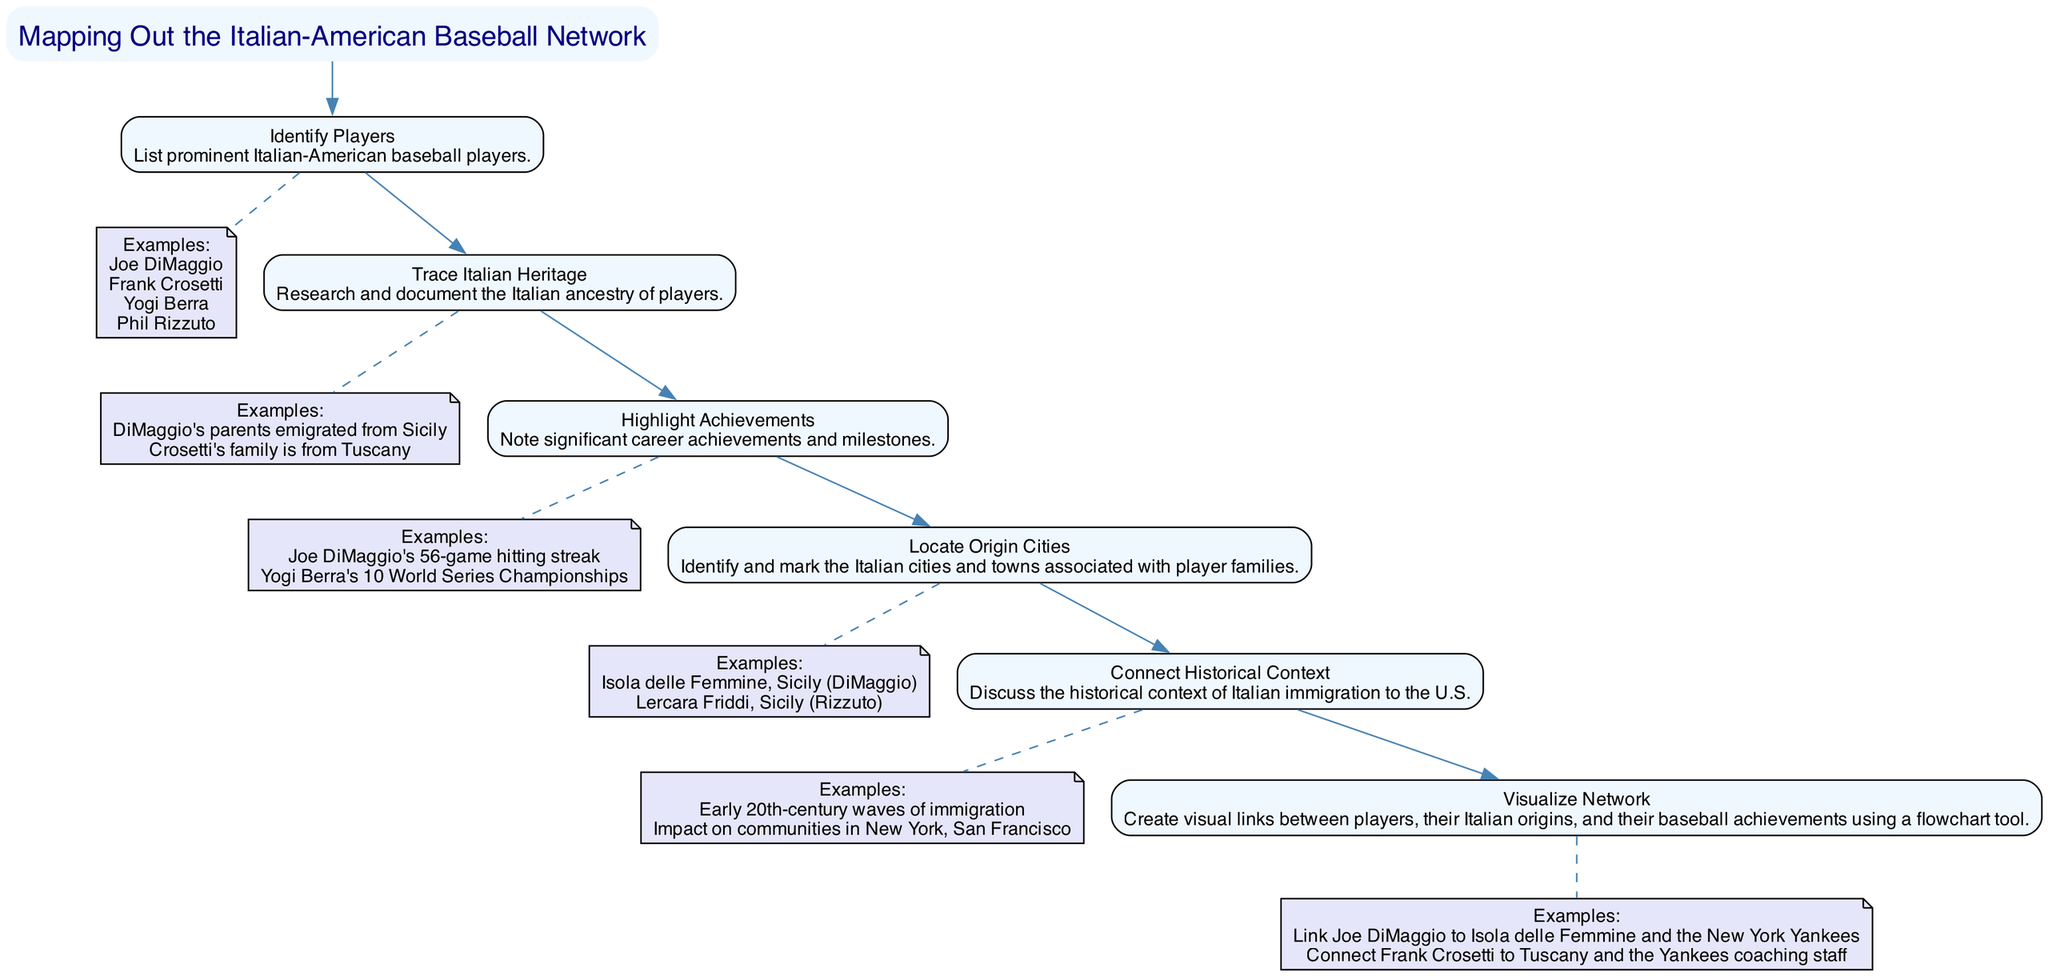What is the first step in the diagram? The first step in the flowchart is "Identify Players." This can be found as the first node after the title, which outlines the initial action in mapping out the Italian-American baseball network.
Answer: Identify Players How many prominent Italian-American players are listed in the examples of the first step? In the first step, there are four examples of prominent Italian-American players provided: Joe DiMaggio, Frank Crosetti, Yogi Berra, and Phil Rizzuto.
Answer: 4 Which player's parents emigrated from Sicily? The flowchart states that Joe DiMaggio's parents emigrated from Sicily in the second step, where it details the Italian ancestry of the players.
Answer: Joe DiMaggio What is the significant achievement listed for Yogi Berra? The flowchart mentions Yogi Berra's achievement of 10 World Series Championships in the third step, which highlights the notable accomplishments of the players.
Answer: 10 World Series Championships How many Italian cities are mentioned in the 'Locate Origin Cities' step? There are two cities mentioned in this step: Isola delle Femmine, Sicily (DiMaggio) and Lercara Friddi, Sicily (Rizzuto). Each player is connected to their respective origin cities listed in the flowchart.
Answer: 2 What does the 'Connect Historical Context' step discuss? This step discusses the historical context of Italian immigration to the U.S., specifically focusing on early 20th-century waves of immigration and their impact on communities, as described in the details of that node.
Answer: Historical context of Italian immigration Which step follows 'Highlight Achievements'? The 'Locate Origin Cities' step follows 'Highlight Achievements' in the sequence of the flowchart, showcasing the next action after recognizing player accomplishments.
Answer: Locate Origin Cities What type of tool is recommended for visualizing the network? The flowchart advocates using a flowchart tool for visualizing the connections between players, their origins, and achievements, as indicated in the sixth step.
Answer: Flowchart tool What is the last step in the flowchart? The last step in the flowchart is 'Visualize Network,' which signifies the final action to illustrate the connections created throughout the previous steps.
Answer: Visualize Network 